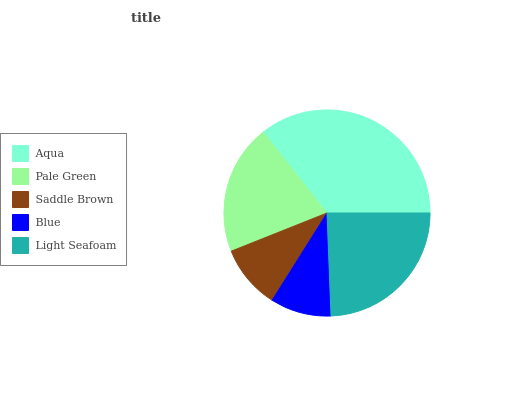Is Blue the minimum?
Answer yes or no. Yes. Is Aqua the maximum?
Answer yes or no. Yes. Is Pale Green the minimum?
Answer yes or no. No. Is Pale Green the maximum?
Answer yes or no. No. Is Aqua greater than Pale Green?
Answer yes or no. Yes. Is Pale Green less than Aqua?
Answer yes or no. Yes. Is Pale Green greater than Aqua?
Answer yes or no. No. Is Aqua less than Pale Green?
Answer yes or no. No. Is Pale Green the high median?
Answer yes or no. Yes. Is Pale Green the low median?
Answer yes or no. Yes. Is Light Seafoam the high median?
Answer yes or no. No. Is Aqua the low median?
Answer yes or no. No. 